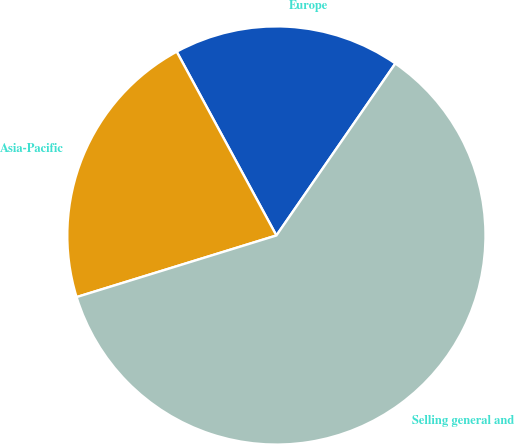Convert chart to OTSL. <chart><loc_0><loc_0><loc_500><loc_500><pie_chart><fcel>Europe<fcel>Asia-Pacific<fcel>Selling general and<nl><fcel>17.54%<fcel>21.85%<fcel>60.61%<nl></chart> 